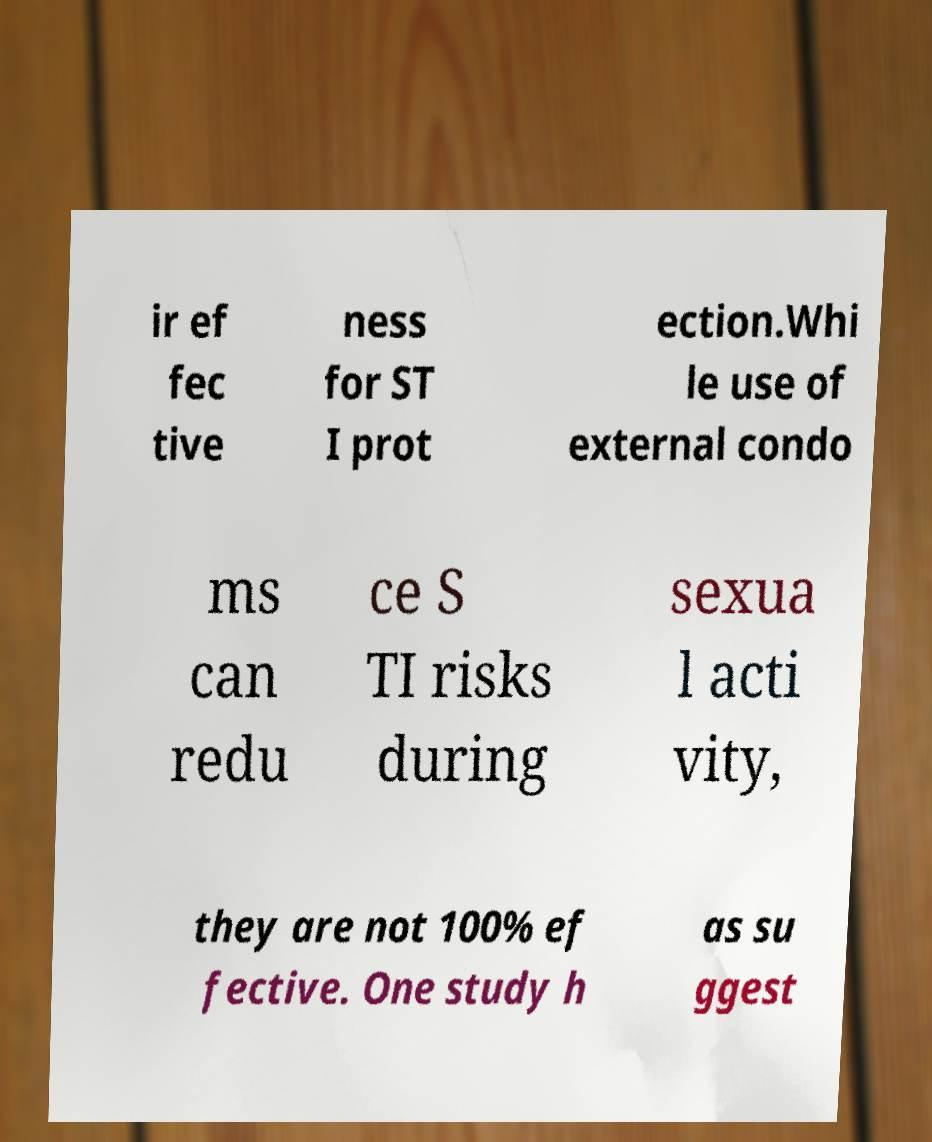Can you accurately transcribe the text from the provided image for me? ir ef fec tive ness for ST I prot ection.Whi le use of external condo ms can redu ce S TI risks during sexua l acti vity, they are not 100% ef fective. One study h as su ggest 